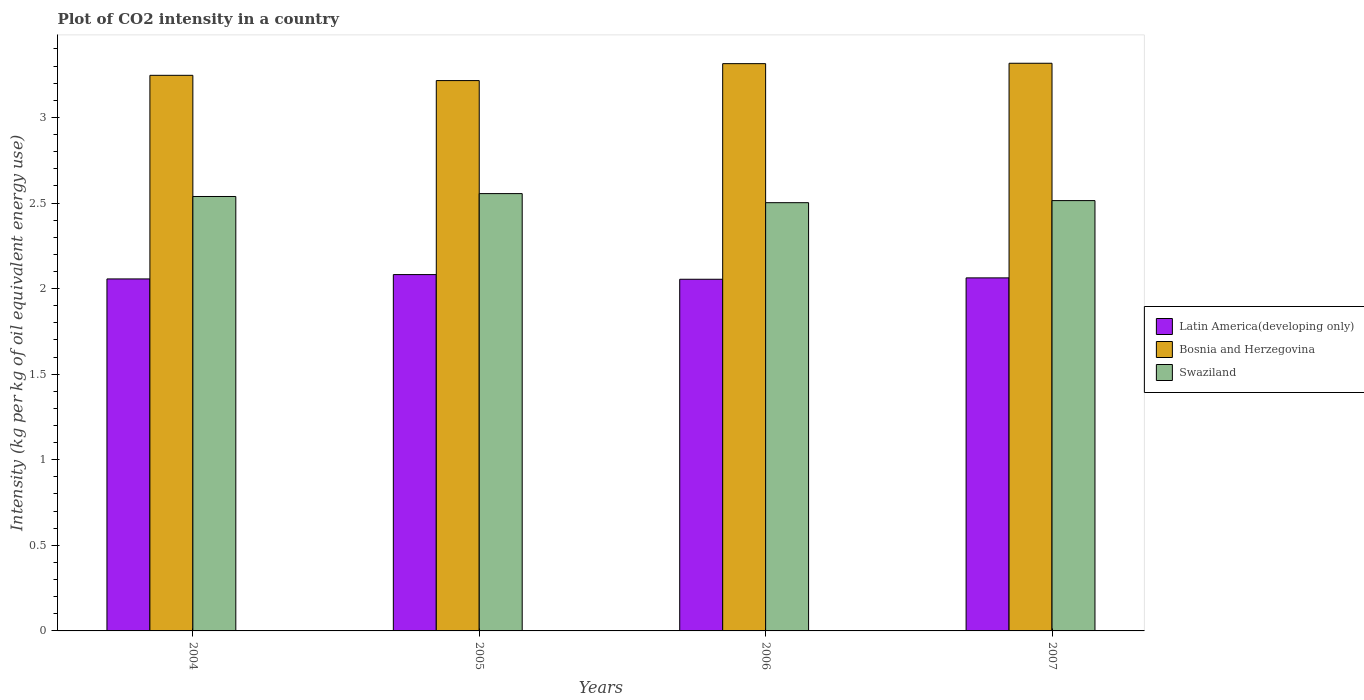How many groups of bars are there?
Make the answer very short. 4. How many bars are there on the 3rd tick from the right?
Your response must be concise. 3. What is the label of the 2nd group of bars from the left?
Ensure brevity in your answer.  2005. What is the CO2 intensity in in Bosnia and Herzegovina in 2007?
Your answer should be very brief. 3.32. Across all years, what is the maximum CO2 intensity in in Swaziland?
Give a very brief answer. 2.55. Across all years, what is the minimum CO2 intensity in in Swaziland?
Offer a terse response. 2.5. In which year was the CO2 intensity in in Latin America(developing only) maximum?
Your answer should be compact. 2005. What is the total CO2 intensity in in Bosnia and Herzegovina in the graph?
Your answer should be very brief. 13.09. What is the difference between the CO2 intensity in in Bosnia and Herzegovina in 2005 and that in 2006?
Give a very brief answer. -0.1. What is the difference between the CO2 intensity in in Latin America(developing only) in 2007 and the CO2 intensity in in Bosnia and Herzegovina in 2004?
Provide a short and direct response. -1.18. What is the average CO2 intensity in in Bosnia and Herzegovina per year?
Give a very brief answer. 3.27. In the year 2004, what is the difference between the CO2 intensity in in Latin America(developing only) and CO2 intensity in in Bosnia and Herzegovina?
Provide a succinct answer. -1.19. What is the ratio of the CO2 intensity in in Bosnia and Herzegovina in 2004 to that in 2005?
Provide a succinct answer. 1.01. Is the CO2 intensity in in Latin America(developing only) in 2004 less than that in 2007?
Make the answer very short. Yes. Is the difference between the CO2 intensity in in Latin America(developing only) in 2004 and 2007 greater than the difference between the CO2 intensity in in Bosnia and Herzegovina in 2004 and 2007?
Your answer should be very brief. Yes. What is the difference between the highest and the second highest CO2 intensity in in Latin America(developing only)?
Make the answer very short. 0.02. What is the difference between the highest and the lowest CO2 intensity in in Swaziland?
Ensure brevity in your answer.  0.05. What does the 3rd bar from the left in 2004 represents?
Offer a very short reply. Swaziland. What does the 3rd bar from the right in 2004 represents?
Offer a very short reply. Latin America(developing only). Is it the case that in every year, the sum of the CO2 intensity in in Bosnia and Herzegovina and CO2 intensity in in Latin America(developing only) is greater than the CO2 intensity in in Swaziland?
Your answer should be compact. Yes. Are the values on the major ticks of Y-axis written in scientific E-notation?
Offer a very short reply. No. Does the graph contain any zero values?
Your response must be concise. No. Where does the legend appear in the graph?
Keep it short and to the point. Center right. What is the title of the graph?
Your answer should be very brief. Plot of CO2 intensity in a country. Does "Guam" appear as one of the legend labels in the graph?
Provide a succinct answer. No. What is the label or title of the X-axis?
Keep it short and to the point. Years. What is the label or title of the Y-axis?
Ensure brevity in your answer.  Intensity (kg per kg of oil equivalent energy use). What is the Intensity (kg per kg of oil equivalent energy use) in Latin America(developing only) in 2004?
Your response must be concise. 2.06. What is the Intensity (kg per kg of oil equivalent energy use) in Bosnia and Herzegovina in 2004?
Keep it short and to the point. 3.25. What is the Intensity (kg per kg of oil equivalent energy use) of Swaziland in 2004?
Offer a very short reply. 2.54. What is the Intensity (kg per kg of oil equivalent energy use) in Latin America(developing only) in 2005?
Offer a very short reply. 2.08. What is the Intensity (kg per kg of oil equivalent energy use) in Bosnia and Herzegovina in 2005?
Your response must be concise. 3.22. What is the Intensity (kg per kg of oil equivalent energy use) in Swaziland in 2005?
Make the answer very short. 2.55. What is the Intensity (kg per kg of oil equivalent energy use) of Latin America(developing only) in 2006?
Offer a terse response. 2.05. What is the Intensity (kg per kg of oil equivalent energy use) of Bosnia and Herzegovina in 2006?
Offer a very short reply. 3.31. What is the Intensity (kg per kg of oil equivalent energy use) in Swaziland in 2006?
Keep it short and to the point. 2.5. What is the Intensity (kg per kg of oil equivalent energy use) in Latin America(developing only) in 2007?
Ensure brevity in your answer.  2.06. What is the Intensity (kg per kg of oil equivalent energy use) in Bosnia and Herzegovina in 2007?
Keep it short and to the point. 3.32. What is the Intensity (kg per kg of oil equivalent energy use) in Swaziland in 2007?
Offer a very short reply. 2.51. Across all years, what is the maximum Intensity (kg per kg of oil equivalent energy use) of Latin America(developing only)?
Offer a terse response. 2.08. Across all years, what is the maximum Intensity (kg per kg of oil equivalent energy use) of Bosnia and Herzegovina?
Offer a very short reply. 3.32. Across all years, what is the maximum Intensity (kg per kg of oil equivalent energy use) in Swaziland?
Offer a terse response. 2.55. Across all years, what is the minimum Intensity (kg per kg of oil equivalent energy use) in Latin America(developing only)?
Keep it short and to the point. 2.05. Across all years, what is the minimum Intensity (kg per kg of oil equivalent energy use) of Bosnia and Herzegovina?
Provide a succinct answer. 3.22. Across all years, what is the minimum Intensity (kg per kg of oil equivalent energy use) of Swaziland?
Offer a terse response. 2.5. What is the total Intensity (kg per kg of oil equivalent energy use) of Latin America(developing only) in the graph?
Make the answer very short. 8.26. What is the total Intensity (kg per kg of oil equivalent energy use) of Bosnia and Herzegovina in the graph?
Ensure brevity in your answer.  13.09. What is the total Intensity (kg per kg of oil equivalent energy use) in Swaziland in the graph?
Offer a very short reply. 10.11. What is the difference between the Intensity (kg per kg of oil equivalent energy use) of Latin America(developing only) in 2004 and that in 2005?
Provide a succinct answer. -0.03. What is the difference between the Intensity (kg per kg of oil equivalent energy use) in Bosnia and Herzegovina in 2004 and that in 2005?
Offer a very short reply. 0.03. What is the difference between the Intensity (kg per kg of oil equivalent energy use) in Swaziland in 2004 and that in 2005?
Keep it short and to the point. -0.02. What is the difference between the Intensity (kg per kg of oil equivalent energy use) of Latin America(developing only) in 2004 and that in 2006?
Your answer should be compact. 0. What is the difference between the Intensity (kg per kg of oil equivalent energy use) of Bosnia and Herzegovina in 2004 and that in 2006?
Provide a short and direct response. -0.07. What is the difference between the Intensity (kg per kg of oil equivalent energy use) in Swaziland in 2004 and that in 2006?
Offer a very short reply. 0.04. What is the difference between the Intensity (kg per kg of oil equivalent energy use) of Latin America(developing only) in 2004 and that in 2007?
Give a very brief answer. -0.01. What is the difference between the Intensity (kg per kg of oil equivalent energy use) in Bosnia and Herzegovina in 2004 and that in 2007?
Provide a short and direct response. -0.07. What is the difference between the Intensity (kg per kg of oil equivalent energy use) of Swaziland in 2004 and that in 2007?
Ensure brevity in your answer.  0.02. What is the difference between the Intensity (kg per kg of oil equivalent energy use) in Latin America(developing only) in 2005 and that in 2006?
Your answer should be compact. 0.03. What is the difference between the Intensity (kg per kg of oil equivalent energy use) of Bosnia and Herzegovina in 2005 and that in 2006?
Provide a short and direct response. -0.1. What is the difference between the Intensity (kg per kg of oil equivalent energy use) in Swaziland in 2005 and that in 2006?
Your response must be concise. 0.05. What is the difference between the Intensity (kg per kg of oil equivalent energy use) of Latin America(developing only) in 2005 and that in 2007?
Your response must be concise. 0.02. What is the difference between the Intensity (kg per kg of oil equivalent energy use) in Bosnia and Herzegovina in 2005 and that in 2007?
Provide a succinct answer. -0.1. What is the difference between the Intensity (kg per kg of oil equivalent energy use) of Swaziland in 2005 and that in 2007?
Make the answer very short. 0.04. What is the difference between the Intensity (kg per kg of oil equivalent energy use) in Latin America(developing only) in 2006 and that in 2007?
Keep it short and to the point. -0.01. What is the difference between the Intensity (kg per kg of oil equivalent energy use) in Bosnia and Herzegovina in 2006 and that in 2007?
Your response must be concise. -0. What is the difference between the Intensity (kg per kg of oil equivalent energy use) in Swaziland in 2006 and that in 2007?
Offer a terse response. -0.01. What is the difference between the Intensity (kg per kg of oil equivalent energy use) of Latin America(developing only) in 2004 and the Intensity (kg per kg of oil equivalent energy use) of Bosnia and Herzegovina in 2005?
Your response must be concise. -1.16. What is the difference between the Intensity (kg per kg of oil equivalent energy use) of Latin America(developing only) in 2004 and the Intensity (kg per kg of oil equivalent energy use) of Swaziland in 2005?
Keep it short and to the point. -0.5. What is the difference between the Intensity (kg per kg of oil equivalent energy use) in Bosnia and Herzegovina in 2004 and the Intensity (kg per kg of oil equivalent energy use) in Swaziland in 2005?
Your answer should be compact. 0.69. What is the difference between the Intensity (kg per kg of oil equivalent energy use) of Latin America(developing only) in 2004 and the Intensity (kg per kg of oil equivalent energy use) of Bosnia and Herzegovina in 2006?
Give a very brief answer. -1.26. What is the difference between the Intensity (kg per kg of oil equivalent energy use) in Latin America(developing only) in 2004 and the Intensity (kg per kg of oil equivalent energy use) in Swaziland in 2006?
Make the answer very short. -0.45. What is the difference between the Intensity (kg per kg of oil equivalent energy use) in Bosnia and Herzegovina in 2004 and the Intensity (kg per kg of oil equivalent energy use) in Swaziland in 2006?
Ensure brevity in your answer.  0.74. What is the difference between the Intensity (kg per kg of oil equivalent energy use) in Latin America(developing only) in 2004 and the Intensity (kg per kg of oil equivalent energy use) in Bosnia and Herzegovina in 2007?
Offer a very short reply. -1.26. What is the difference between the Intensity (kg per kg of oil equivalent energy use) in Latin America(developing only) in 2004 and the Intensity (kg per kg of oil equivalent energy use) in Swaziland in 2007?
Provide a short and direct response. -0.46. What is the difference between the Intensity (kg per kg of oil equivalent energy use) in Bosnia and Herzegovina in 2004 and the Intensity (kg per kg of oil equivalent energy use) in Swaziland in 2007?
Make the answer very short. 0.73. What is the difference between the Intensity (kg per kg of oil equivalent energy use) of Latin America(developing only) in 2005 and the Intensity (kg per kg of oil equivalent energy use) of Bosnia and Herzegovina in 2006?
Your response must be concise. -1.23. What is the difference between the Intensity (kg per kg of oil equivalent energy use) in Latin America(developing only) in 2005 and the Intensity (kg per kg of oil equivalent energy use) in Swaziland in 2006?
Provide a short and direct response. -0.42. What is the difference between the Intensity (kg per kg of oil equivalent energy use) of Bosnia and Herzegovina in 2005 and the Intensity (kg per kg of oil equivalent energy use) of Swaziland in 2006?
Ensure brevity in your answer.  0.71. What is the difference between the Intensity (kg per kg of oil equivalent energy use) of Latin America(developing only) in 2005 and the Intensity (kg per kg of oil equivalent energy use) of Bosnia and Herzegovina in 2007?
Offer a terse response. -1.23. What is the difference between the Intensity (kg per kg of oil equivalent energy use) of Latin America(developing only) in 2005 and the Intensity (kg per kg of oil equivalent energy use) of Swaziland in 2007?
Keep it short and to the point. -0.43. What is the difference between the Intensity (kg per kg of oil equivalent energy use) of Bosnia and Herzegovina in 2005 and the Intensity (kg per kg of oil equivalent energy use) of Swaziland in 2007?
Your response must be concise. 0.7. What is the difference between the Intensity (kg per kg of oil equivalent energy use) in Latin America(developing only) in 2006 and the Intensity (kg per kg of oil equivalent energy use) in Bosnia and Herzegovina in 2007?
Ensure brevity in your answer.  -1.26. What is the difference between the Intensity (kg per kg of oil equivalent energy use) in Latin America(developing only) in 2006 and the Intensity (kg per kg of oil equivalent energy use) in Swaziland in 2007?
Offer a very short reply. -0.46. What is the difference between the Intensity (kg per kg of oil equivalent energy use) of Bosnia and Herzegovina in 2006 and the Intensity (kg per kg of oil equivalent energy use) of Swaziland in 2007?
Offer a very short reply. 0.8. What is the average Intensity (kg per kg of oil equivalent energy use) in Latin America(developing only) per year?
Give a very brief answer. 2.06. What is the average Intensity (kg per kg of oil equivalent energy use) of Bosnia and Herzegovina per year?
Ensure brevity in your answer.  3.27. What is the average Intensity (kg per kg of oil equivalent energy use) in Swaziland per year?
Ensure brevity in your answer.  2.53. In the year 2004, what is the difference between the Intensity (kg per kg of oil equivalent energy use) in Latin America(developing only) and Intensity (kg per kg of oil equivalent energy use) in Bosnia and Herzegovina?
Offer a very short reply. -1.19. In the year 2004, what is the difference between the Intensity (kg per kg of oil equivalent energy use) in Latin America(developing only) and Intensity (kg per kg of oil equivalent energy use) in Swaziland?
Ensure brevity in your answer.  -0.48. In the year 2004, what is the difference between the Intensity (kg per kg of oil equivalent energy use) in Bosnia and Herzegovina and Intensity (kg per kg of oil equivalent energy use) in Swaziland?
Keep it short and to the point. 0.71. In the year 2005, what is the difference between the Intensity (kg per kg of oil equivalent energy use) of Latin America(developing only) and Intensity (kg per kg of oil equivalent energy use) of Bosnia and Herzegovina?
Give a very brief answer. -1.13. In the year 2005, what is the difference between the Intensity (kg per kg of oil equivalent energy use) in Latin America(developing only) and Intensity (kg per kg of oil equivalent energy use) in Swaziland?
Your answer should be compact. -0.47. In the year 2005, what is the difference between the Intensity (kg per kg of oil equivalent energy use) of Bosnia and Herzegovina and Intensity (kg per kg of oil equivalent energy use) of Swaziland?
Keep it short and to the point. 0.66. In the year 2006, what is the difference between the Intensity (kg per kg of oil equivalent energy use) in Latin America(developing only) and Intensity (kg per kg of oil equivalent energy use) in Bosnia and Herzegovina?
Give a very brief answer. -1.26. In the year 2006, what is the difference between the Intensity (kg per kg of oil equivalent energy use) of Latin America(developing only) and Intensity (kg per kg of oil equivalent energy use) of Swaziland?
Provide a succinct answer. -0.45. In the year 2006, what is the difference between the Intensity (kg per kg of oil equivalent energy use) in Bosnia and Herzegovina and Intensity (kg per kg of oil equivalent energy use) in Swaziland?
Keep it short and to the point. 0.81. In the year 2007, what is the difference between the Intensity (kg per kg of oil equivalent energy use) in Latin America(developing only) and Intensity (kg per kg of oil equivalent energy use) in Bosnia and Herzegovina?
Offer a very short reply. -1.25. In the year 2007, what is the difference between the Intensity (kg per kg of oil equivalent energy use) in Latin America(developing only) and Intensity (kg per kg of oil equivalent energy use) in Swaziland?
Provide a succinct answer. -0.45. In the year 2007, what is the difference between the Intensity (kg per kg of oil equivalent energy use) of Bosnia and Herzegovina and Intensity (kg per kg of oil equivalent energy use) of Swaziland?
Make the answer very short. 0.8. What is the ratio of the Intensity (kg per kg of oil equivalent energy use) in Latin America(developing only) in 2004 to that in 2005?
Provide a succinct answer. 0.99. What is the ratio of the Intensity (kg per kg of oil equivalent energy use) in Bosnia and Herzegovina in 2004 to that in 2005?
Keep it short and to the point. 1.01. What is the ratio of the Intensity (kg per kg of oil equivalent energy use) in Bosnia and Herzegovina in 2004 to that in 2006?
Offer a terse response. 0.98. What is the ratio of the Intensity (kg per kg of oil equivalent energy use) of Swaziland in 2004 to that in 2006?
Provide a short and direct response. 1.01. What is the ratio of the Intensity (kg per kg of oil equivalent energy use) of Latin America(developing only) in 2004 to that in 2007?
Your response must be concise. 1. What is the ratio of the Intensity (kg per kg of oil equivalent energy use) of Bosnia and Herzegovina in 2004 to that in 2007?
Your answer should be compact. 0.98. What is the ratio of the Intensity (kg per kg of oil equivalent energy use) of Swaziland in 2004 to that in 2007?
Make the answer very short. 1.01. What is the ratio of the Intensity (kg per kg of oil equivalent energy use) of Latin America(developing only) in 2005 to that in 2006?
Keep it short and to the point. 1.01. What is the ratio of the Intensity (kg per kg of oil equivalent energy use) of Bosnia and Herzegovina in 2005 to that in 2006?
Your answer should be very brief. 0.97. What is the ratio of the Intensity (kg per kg of oil equivalent energy use) of Swaziland in 2005 to that in 2006?
Give a very brief answer. 1.02. What is the ratio of the Intensity (kg per kg of oil equivalent energy use) in Latin America(developing only) in 2005 to that in 2007?
Provide a short and direct response. 1.01. What is the ratio of the Intensity (kg per kg of oil equivalent energy use) in Bosnia and Herzegovina in 2005 to that in 2007?
Your answer should be very brief. 0.97. What is the ratio of the Intensity (kg per kg of oil equivalent energy use) in Swaziland in 2005 to that in 2007?
Offer a terse response. 1.02. What is the ratio of the Intensity (kg per kg of oil equivalent energy use) of Bosnia and Herzegovina in 2006 to that in 2007?
Ensure brevity in your answer.  1. What is the difference between the highest and the second highest Intensity (kg per kg of oil equivalent energy use) in Latin America(developing only)?
Keep it short and to the point. 0.02. What is the difference between the highest and the second highest Intensity (kg per kg of oil equivalent energy use) in Bosnia and Herzegovina?
Your answer should be compact. 0. What is the difference between the highest and the second highest Intensity (kg per kg of oil equivalent energy use) in Swaziland?
Offer a very short reply. 0.02. What is the difference between the highest and the lowest Intensity (kg per kg of oil equivalent energy use) in Latin America(developing only)?
Your response must be concise. 0.03. What is the difference between the highest and the lowest Intensity (kg per kg of oil equivalent energy use) of Bosnia and Herzegovina?
Keep it short and to the point. 0.1. What is the difference between the highest and the lowest Intensity (kg per kg of oil equivalent energy use) of Swaziland?
Your response must be concise. 0.05. 